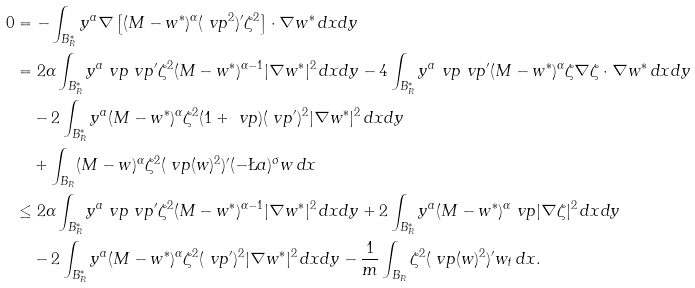<formula> <loc_0><loc_0><loc_500><loc_500>0 & = - \int _ { B _ { R } ^ { \ast } } y ^ { a } \nabla \left [ ( M - w ^ { \ast } ) ^ { \alpha } ( \ v p ^ { 2 } ) ^ { \prime } \zeta ^ { 2 } \right ] \cdot \nabla w ^ { \ast } \, d x d y \\ & = 2 \alpha \int _ { B _ { R } ^ { \ast } } y ^ { a } \ v p \ v p ^ { \prime } \zeta ^ { 2 } ( M - w ^ { \ast } ) ^ { \alpha - 1 } | \nabla w ^ { \ast } | ^ { 2 } \, d x d y - 4 \int _ { B _ { R } ^ { \ast } } y ^ { a } \ v p \ v p ^ { \prime } ( M - w ^ { \ast } ) ^ { \alpha } \zeta \nabla \zeta \cdot \nabla w ^ { \ast } \, d x d y \\ & \quad - 2 \int _ { B _ { R } ^ { \ast } } y ^ { a } ( M - w ^ { \ast } ) ^ { \alpha } \zeta ^ { 2 } ( 1 + \ v p ) ( \ v p ^ { \prime } ) ^ { 2 } | \nabla w ^ { \ast } | ^ { 2 } \, d x d y \\ & \quad + \int _ { B _ { R } } ( M - w ) ^ { \alpha } \zeta ^ { 2 } ( \ v p ( w ) ^ { 2 } ) ^ { \prime } ( - \L a ) ^ { \sigma } w \, d x \\ & \leq 2 \alpha \int _ { B _ { R } ^ { \ast } } y ^ { a } \ v p \ v p ^ { \prime } \zeta ^ { 2 } ( M - w ^ { \ast } ) ^ { \alpha - 1 } | \nabla w ^ { \ast } | ^ { 2 } \, d x d y + 2 \int _ { B ^ { \ast } _ { R } } y ^ { a } ( M - w ^ { \ast } ) ^ { \alpha } \ v p | \nabla \zeta | ^ { 2 } \, d x d y \\ & \quad - 2 \int _ { B _ { R } ^ { \ast } } y ^ { a } ( M - w ^ { \ast } ) ^ { \alpha } \zeta ^ { 2 } ( \ v p ^ { \prime } ) ^ { 2 } | \nabla w ^ { \ast } | ^ { 2 } \, d x d y - \frac { 1 } { m } \int _ { B _ { R } } \zeta ^ { 2 } ( \ v p ( w ) ^ { 2 } ) ^ { \prime } w _ { t } \, d x .</formula> 